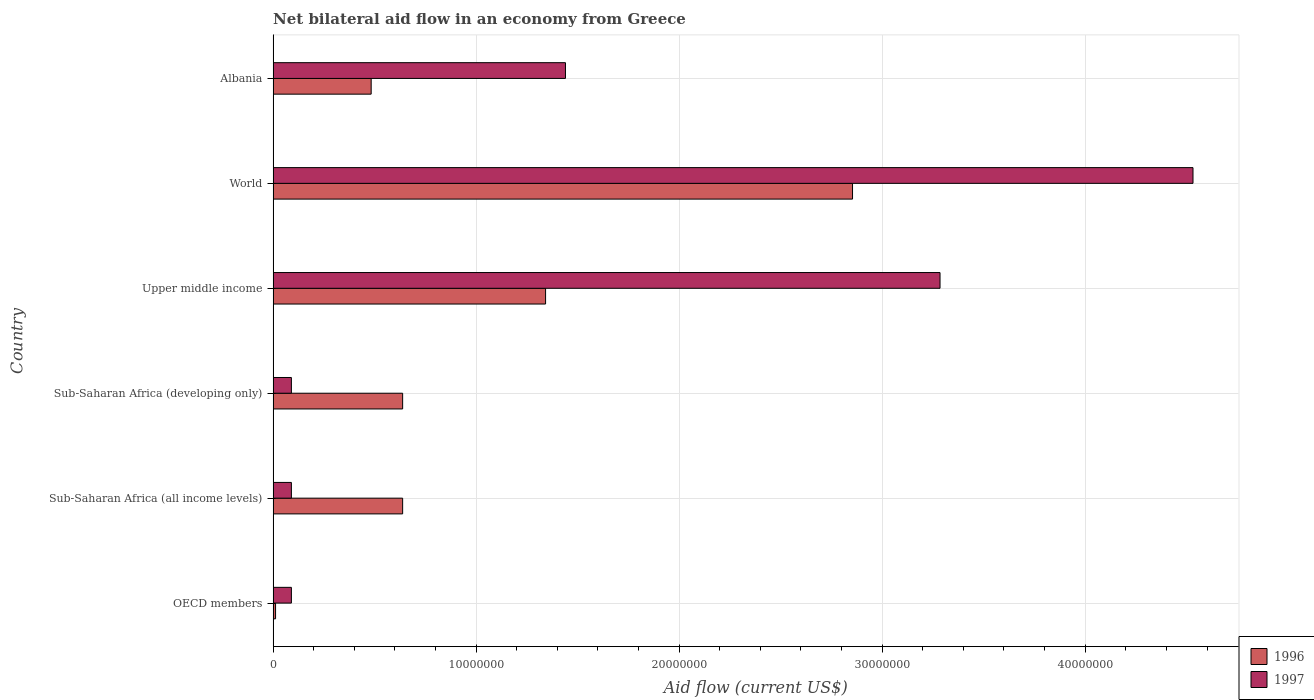Are the number of bars per tick equal to the number of legend labels?
Offer a very short reply. Yes. What is the label of the 5th group of bars from the top?
Offer a very short reply. Sub-Saharan Africa (all income levels). What is the net bilateral aid flow in 1996 in Albania?
Offer a very short reply. 4.83e+06. Across all countries, what is the maximum net bilateral aid flow in 1997?
Your answer should be very brief. 4.53e+07. Across all countries, what is the minimum net bilateral aid flow in 1997?
Ensure brevity in your answer.  9.00e+05. In which country was the net bilateral aid flow in 1997 minimum?
Provide a short and direct response. OECD members. What is the total net bilateral aid flow in 1997 in the graph?
Keep it short and to the point. 9.53e+07. What is the difference between the net bilateral aid flow in 1997 in Upper middle income and that in World?
Offer a very short reply. -1.25e+07. What is the difference between the net bilateral aid flow in 1997 in Upper middle income and the net bilateral aid flow in 1996 in World?
Provide a succinct answer. 4.31e+06. What is the average net bilateral aid flow in 1997 per country?
Offer a very short reply. 1.59e+07. What is the difference between the net bilateral aid flow in 1996 and net bilateral aid flow in 1997 in Sub-Saharan Africa (all income levels)?
Provide a short and direct response. 5.48e+06. In how many countries, is the net bilateral aid flow in 1996 greater than 40000000 US$?
Your answer should be compact. 0. What is the ratio of the net bilateral aid flow in 1996 in Sub-Saharan Africa (all income levels) to that in World?
Make the answer very short. 0.22. What is the difference between the highest and the second highest net bilateral aid flow in 1997?
Make the answer very short. 1.25e+07. What is the difference between the highest and the lowest net bilateral aid flow in 1996?
Your response must be concise. 2.84e+07. In how many countries, is the net bilateral aid flow in 1997 greater than the average net bilateral aid flow in 1997 taken over all countries?
Offer a terse response. 2. What does the 1st bar from the bottom in Sub-Saharan Africa (all income levels) represents?
Give a very brief answer. 1996. How many bars are there?
Provide a succinct answer. 12. Are all the bars in the graph horizontal?
Ensure brevity in your answer.  Yes. How many countries are there in the graph?
Offer a terse response. 6. Does the graph contain any zero values?
Ensure brevity in your answer.  No. Does the graph contain grids?
Make the answer very short. Yes. Where does the legend appear in the graph?
Your answer should be very brief. Bottom right. How are the legend labels stacked?
Provide a succinct answer. Vertical. What is the title of the graph?
Provide a short and direct response. Net bilateral aid flow in an economy from Greece. What is the label or title of the X-axis?
Make the answer very short. Aid flow (current US$). What is the label or title of the Y-axis?
Your answer should be compact. Country. What is the Aid flow (current US$) of 1996 in OECD members?
Your response must be concise. 1.20e+05. What is the Aid flow (current US$) in 1997 in OECD members?
Give a very brief answer. 9.00e+05. What is the Aid flow (current US$) in 1996 in Sub-Saharan Africa (all income levels)?
Your answer should be compact. 6.38e+06. What is the Aid flow (current US$) of 1996 in Sub-Saharan Africa (developing only)?
Keep it short and to the point. 6.38e+06. What is the Aid flow (current US$) in 1997 in Sub-Saharan Africa (developing only)?
Your answer should be compact. 9.00e+05. What is the Aid flow (current US$) in 1996 in Upper middle income?
Make the answer very short. 1.34e+07. What is the Aid flow (current US$) in 1997 in Upper middle income?
Give a very brief answer. 3.28e+07. What is the Aid flow (current US$) in 1996 in World?
Provide a short and direct response. 2.85e+07. What is the Aid flow (current US$) of 1997 in World?
Ensure brevity in your answer.  4.53e+07. What is the Aid flow (current US$) of 1996 in Albania?
Keep it short and to the point. 4.83e+06. What is the Aid flow (current US$) of 1997 in Albania?
Offer a very short reply. 1.44e+07. Across all countries, what is the maximum Aid flow (current US$) of 1996?
Keep it short and to the point. 2.85e+07. Across all countries, what is the maximum Aid flow (current US$) of 1997?
Ensure brevity in your answer.  4.53e+07. Across all countries, what is the minimum Aid flow (current US$) of 1996?
Keep it short and to the point. 1.20e+05. What is the total Aid flow (current US$) of 1996 in the graph?
Keep it short and to the point. 5.97e+07. What is the total Aid flow (current US$) in 1997 in the graph?
Ensure brevity in your answer.  9.53e+07. What is the difference between the Aid flow (current US$) in 1996 in OECD members and that in Sub-Saharan Africa (all income levels)?
Offer a very short reply. -6.26e+06. What is the difference between the Aid flow (current US$) in 1996 in OECD members and that in Sub-Saharan Africa (developing only)?
Make the answer very short. -6.26e+06. What is the difference between the Aid flow (current US$) in 1996 in OECD members and that in Upper middle income?
Provide a succinct answer. -1.33e+07. What is the difference between the Aid flow (current US$) of 1997 in OECD members and that in Upper middle income?
Ensure brevity in your answer.  -3.20e+07. What is the difference between the Aid flow (current US$) in 1996 in OECD members and that in World?
Ensure brevity in your answer.  -2.84e+07. What is the difference between the Aid flow (current US$) of 1997 in OECD members and that in World?
Keep it short and to the point. -4.44e+07. What is the difference between the Aid flow (current US$) in 1996 in OECD members and that in Albania?
Provide a succinct answer. -4.71e+06. What is the difference between the Aid flow (current US$) in 1997 in OECD members and that in Albania?
Offer a very short reply. -1.35e+07. What is the difference between the Aid flow (current US$) in 1996 in Sub-Saharan Africa (all income levels) and that in Upper middle income?
Ensure brevity in your answer.  -7.04e+06. What is the difference between the Aid flow (current US$) of 1997 in Sub-Saharan Africa (all income levels) and that in Upper middle income?
Provide a succinct answer. -3.20e+07. What is the difference between the Aid flow (current US$) in 1996 in Sub-Saharan Africa (all income levels) and that in World?
Your answer should be very brief. -2.22e+07. What is the difference between the Aid flow (current US$) in 1997 in Sub-Saharan Africa (all income levels) and that in World?
Provide a short and direct response. -4.44e+07. What is the difference between the Aid flow (current US$) of 1996 in Sub-Saharan Africa (all income levels) and that in Albania?
Keep it short and to the point. 1.55e+06. What is the difference between the Aid flow (current US$) in 1997 in Sub-Saharan Africa (all income levels) and that in Albania?
Provide a short and direct response. -1.35e+07. What is the difference between the Aid flow (current US$) of 1996 in Sub-Saharan Africa (developing only) and that in Upper middle income?
Give a very brief answer. -7.04e+06. What is the difference between the Aid flow (current US$) of 1997 in Sub-Saharan Africa (developing only) and that in Upper middle income?
Offer a terse response. -3.20e+07. What is the difference between the Aid flow (current US$) in 1996 in Sub-Saharan Africa (developing only) and that in World?
Your response must be concise. -2.22e+07. What is the difference between the Aid flow (current US$) in 1997 in Sub-Saharan Africa (developing only) and that in World?
Make the answer very short. -4.44e+07. What is the difference between the Aid flow (current US$) of 1996 in Sub-Saharan Africa (developing only) and that in Albania?
Keep it short and to the point. 1.55e+06. What is the difference between the Aid flow (current US$) of 1997 in Sub-Saharan Africa (developing only) and that in Albania?
Keep it short and to the point. -1.35e+07. What is the difference between the Aid flow (current US$) of 1996 in Upper middle income and that in World?
Ensure brevity in your answer.  -1.51e+07. What is the difference between the Aid flow (current US$) of 1997 in Upper middle income and that in World?
Keep it short and to the point. -1.25e+07. What is the difference between the Aid flow (current US$) in 1996 in Upper middle income and that in Albania?
Provide a succinct answer. 8.59e+06. What is the difference between the Aid flow (current US$) in 1997 in Upper middle income and that in Albania?
Ensure brevity in your answer.  1.84e+07. What is the difference between the Aid flow (current US$) in 1996 in World and that in Albania?
Make the answer very short. 2.37e+07. What is the difference between the Aid flow (current US$) of 1997 in World and that in Albania?
Your answer should be very brief. 3.09e+07. What is the difference between the Aid flow (current US$) in 1996 in OECD members and the Aid flow (current US$) in 1997 in Sub-Saharan Africa (all income levels)?
Make the answer very short. -7.80e+05. What is the difference between the Aid flow (current US$) in 1996 in OECD members and the Aid flow (current US$) in 1997 in Sub-Saharan Africa (developing only)?
Your answer should be compact. -7.80e+05. What is the difference between the Aid flow (current US$) in 1996 in OECD members and the Aid flow (current US$) in 1997 in Upper middle income?
Provide a succinct answer. -3.27e+07. What is the difference between the Aid flow (current US$) of 1996 in OECD members and the Aid flow (current US$) of 1997 in World?
Make the answer very short. -4.52e+07. What is the difference between the Aid flow (current US$) of 1996 in OECD members and the Aid flow (current US$) of 1997 in Albania?
Provide a succinct answer. -1.43e+07. What is the difference between the Aid flow (current US$) of 1996 in Sub-Saharan Africa (all income levels) and the Aid flow (current US$) of 1997 in Sub-Saharan Africa (developing only)?
Offer a terse response. 5.48e+06. What is the difference between the Aid flow (current US$) of 1996 in Sub-Saharan Africa (all income levels) and the Aid flow (current US$) of 1997 in Upper middle income?
Provide a short and direct response. -2.65e+07. What is the difference between the Aid flow (current US$) of 1996 in Sub-Saharan Africa (all income levels) and the Aid flow (current US$) of 1997 in World?
Make the answer very short. -3.89e+07. What is the difference between the Aid flow (current US$) of 1996 in Sub-Saharan Africa (all income levels) and the Aid flow (current US$) of 1997 in Albania?
Your answer should be very brief. -8.02e+06. What is the difference between the Aid flow (current US$) of 1996 in Sub-Saharan Africa (developing only) and the Aid flow (current US$) of 1997 in Upper middle income?
Make the answer very short. -2.65e+07. What is the difference between the Aid flow (current US$) in 1996 in Sub-Saharan Africa (developing only) and the Aid flow (current US$) in 1997 in World?
Ensure brevity in your answer.  -3.89e+07. What is the difference between the Aid flow (current US$) in 1996 in Sub-Saharan Africa (developing only) and the Aid flow (current US$) in 1997 in Albania?
Offer a terse response. -8.02e+06. What is the difference between the Aid flow (current US$) in 1996 in Upper middle income and the Aid flow (current US$) in 1997 in World?
Make the answer very short. -3.19e+07. What is the difference between the Aid flow (current US$) of 1996 in Upper middle income and the Aid flow (current US$) of 1997 in Albania?
Your answer should be compact. -9.80e+05. What is the difference between the Aid flow (current US$) in 1996 in World and the Aid flow (current US$) in 1997 in Albania?
Make the answer very short. 1.41e+07. What is the average Aid flow (current US$) of 1996 per country?
Make the answer very short. 9.94e+06. What is the average Aid flow (current US$) of 1997 per country?
Provide a succinct answer. 1.59e+07. What is the difference between the Aid flow (current US$) in 1996 and Aid flow (current US$) in 1997 in OECD members?
Keep it short and to the point. -7.80e+05. What is the difference between the Aid flow (current US$) of 1996 and Aid flow (current US$) of 1997 in Sub-Saharan Africa (all income levels)?
Your answer should be very brief. 5.48e+06. What is the difference between the Aid flow (current US$) of 1996 and Aid flow (current US$) of 1997 in Sub-Saharan Africa (developing only)?
Offer a very short reply. 5.48e+06. What is the difference between the Aid flow (current US$) in 1996 and Aid flow (current US$) in 1997 in Upper middle income?
Make the answer very short. -1.94e+07. What is the difference between the Aid flow (current US$) of 1996 and Aid flow (current US$) of 1997 in World?
Your answer should be very brief. -1.68e+07. What is the difference between the Aid flow (current US$) in 1996 and Aid flow (current US$) in 1997 in Albania?
Give a very brief answer. -9.57e+06. What is the ratio of the Aid flow (current US$) in 1996 in OECD members to that in Sub-Saharan Africa (all income levels)?
Your answer should be compact. 0.02. What is the ratio of the Aid flow (current US$) of 1996 in OECD members to that in Sub-Saharan Africa (developing only)?
Provide a succinct answer. 0.02. What is the ratio of the Aid flow (current US$) of 1997 in OECD members to that in Sub-Saharan Africa (developing only)?
Provide a succinct answer. 1. What is the ratio of the Aid flow (current US$) of 1996 in OECD members to that in Upper middle income?
Make the answer very short. 0.01. What is the ratio of the Aid flow (current US$) of 1997 in OECD members to that in Upper middle income?
Keep it short and to the point. 0.03. What is the ratio of the Aid flow (current US$) of 1996 in OECD members to that in World?
Make the answer very short. 0. What is the ratio of the Aid flow (current US$) in 1997 in OECD members to that in World?
Ensure brevity in your answer.  0.02. What is the ratio of the Aid flow (current US$) of 1996 in OECD members to that in Albania?
Make the answer very short. 0.02. What is the ratio of the Aid flow (current US$) of 1997 in OECD members to that in Albania?
Your answer should be compact. 0.06. What is the ratio of the Aid flow (current US$) of 1997 in Sub-Saharan Africa (all income levels) to that in Sub-Saharan Africa (developing only)?
Your response must be concise. 1. What is the ratio of the Aid flow (current US$) in 1996 in Sub-Saharan Africa (all income levels) to that in Upper middle income?
Provide a short and direct response. 0.48. What is the ratio of the Aid flow (current US$) in 1997 in Sub-Saharan Africa (all income levels) to that in Upper middle income?
Ensure brevity in your answer.  0.03. What is the ratio of the Aid flow (current US$) of 1996 in Sub-Saharan Africa (all income levels) to that in World?
Your answer should be very brief. 0.22. What is the ratio of the Aid flow (current US$) in 1997 in Sub-Saharan Africa (all income levels) to that in World?
Your answer should be very brief. 0.02. What is the ratio of the Aid flow (current US$) of 1996 in Sub-Saharan Africa (all income levels) to that in Albania?
Offer a terse response. 1.32. What is the ratio of the Aid flow (current US$) in 1997 in Sub-Saharan Africa (all income levels) to that in Albania?
Provide a succinct answer. 0.06. What is the ratio of the Aid flow (current US$) in 1996 in Sub-Saharan Africa (developing only) to that in Upper middle income?
Offer a very short reply. 0.48. What is the ratio of the Aid flow (current US$) of 1997 in Sub-Saharan Africa (developing only) to that in Upper middle income?
Your answer should be very brief. 0.03. What is the ratio of the Aid flow (current US$) of 1996 in Sub-Saharan Africa (developing only) to that in World?
Keep it short and to the point. 0.22. What is the ratio of the Aid flow (current US$) in 1997 in Sub-Saharan Africa (developing only) to that in World?
Keep it short and to the point. 0.02. What is the ratio of the Aid flow (current US$) in 1996 in Sub-Saharan Africa (developing only) to that in Albania?
Your answer should be very brief. 1.32. What is the ratio of the Aid flow (current US$) of 1997 in Sub-Saharan Africa (developing only) to that in Albania?
Offer a terse response. 0.06. What is the ratio of the Aid flow (current US$) in 1996 in Upper middle income to that in World?
Offer a very short reply. 0.47. What is the ratio of the Aid flow (current US$) in 1997 in Upper middle income to that in World?
Offer a very short reply. 0.72. What is the ratio of the Aid flow (current US$) of 1996 in Upper middle income to that in Albania?
Provide a short and direct response. 2.78. What is the ratio of the Aid flow (current US$) of 1997 in Upper middle income to that in Albania?
Offer a terse response. 2.28. What is the ratio of the Aid flow (current US$) of 1996 in World to that in Albania?
Your answer should be very brief. 5.91. What is the ratio of the Aid flow (current US$) in 1997 in World to that in Albania?
Provide a succinct answer. 3.15. What is the difference between the highest and the second highest Aid flow (current US$) in 1996?
Ensure brevity in your answer.  1.51e+07. What is the difference between the highest and the second highest Aid flow (current US$) in 1997?
Give a very brief answer. 1.25e+07. What is the difference between the highest and the lowest Aid flow (current US$) of 1996?
Give a very brief answer. 2.84e+07. What is the difference between the highest and the lowest Aid flow (current US$) of 1997?
Provide a short and direct response. 4.44e+07. 